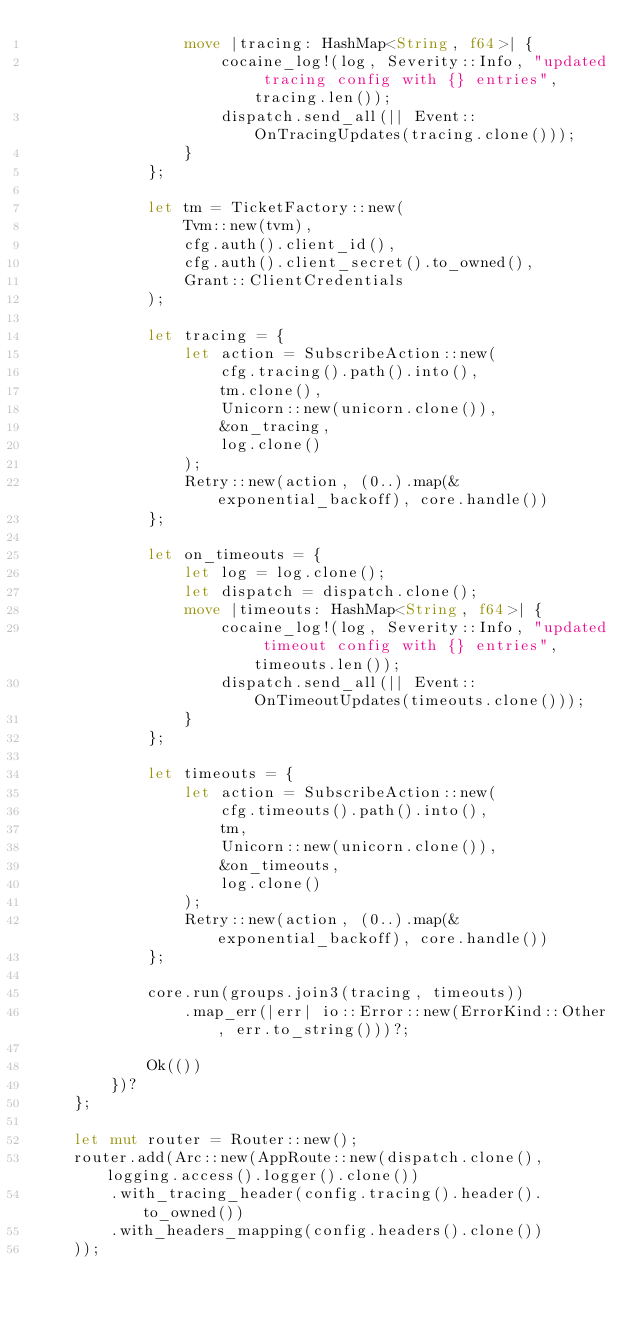<code> <loc_0><loc_0><loc_500><loc_500><_Rust_>                move |tracing: HashMap<String, f64>| {
                    cocaine_log!(log, Severity::Info, "updated tracing config with {} entries", tracing.len());
                    dispatch.send_all(|| Event::OnTracingUpdates(tracing.clone()));
                }
            };

            let tm = TicketFactory::new(
                Tvm::new(tvm),
                cfg.auth().client_id(),
                cfg.auth().client_secret().to_owned(),
                Grant::ClientCredentials
            );

            let tracing = {
                let action = SubscribeAction::new(
                    cfg.tracing().path().into(),
                    tm.clone(),
                    Unicorn::new(unicorn.clone()),
                    &on_tracing,
                    log.clone()
                );
                Retry::new(action, (0..).map(&exponential_backoff), core.handle())
            };

            let on_timeouts = {
                let log = log.clone();
                let dispatch = dispatch.clone();
                move |timeouts: HashMap<String, f64>| {
                    cocaine_log!(log, Severity::Info, "updated timeout config with {} entries", timeouts.len());
                    dispatch.send_all(|| Event::OnTimeoutUpdates(timeouts.clone()));
                }
            };

            let timeouts = {
                let action = SubscribeAction::new(
                    cfg.timeouts().path().into(),
                    tm,
                    Unicorn::new(unicorn.clone()),
                    &on_timeouts,
                    log.clone()
                );
                Retry::new(action, (0..).map(&exponential_backoff), core.handle())
            };

            core.run(groups.join3(tracing, timeouts))
                .map_err(|err| io::Error::new(ErrorKind::Other, err.to_string()))?;

            Ok(())
        })?
    };

    let mut router = Router::new();
    router.add(Arc::new(AppRoute::new(dispatch.clone(), logging.access().logger().clone())
        .with_tracing_header(config.tracing().header().to_owned())
        .with_headers_mapping(config.headers().clone())
    ));</code> 